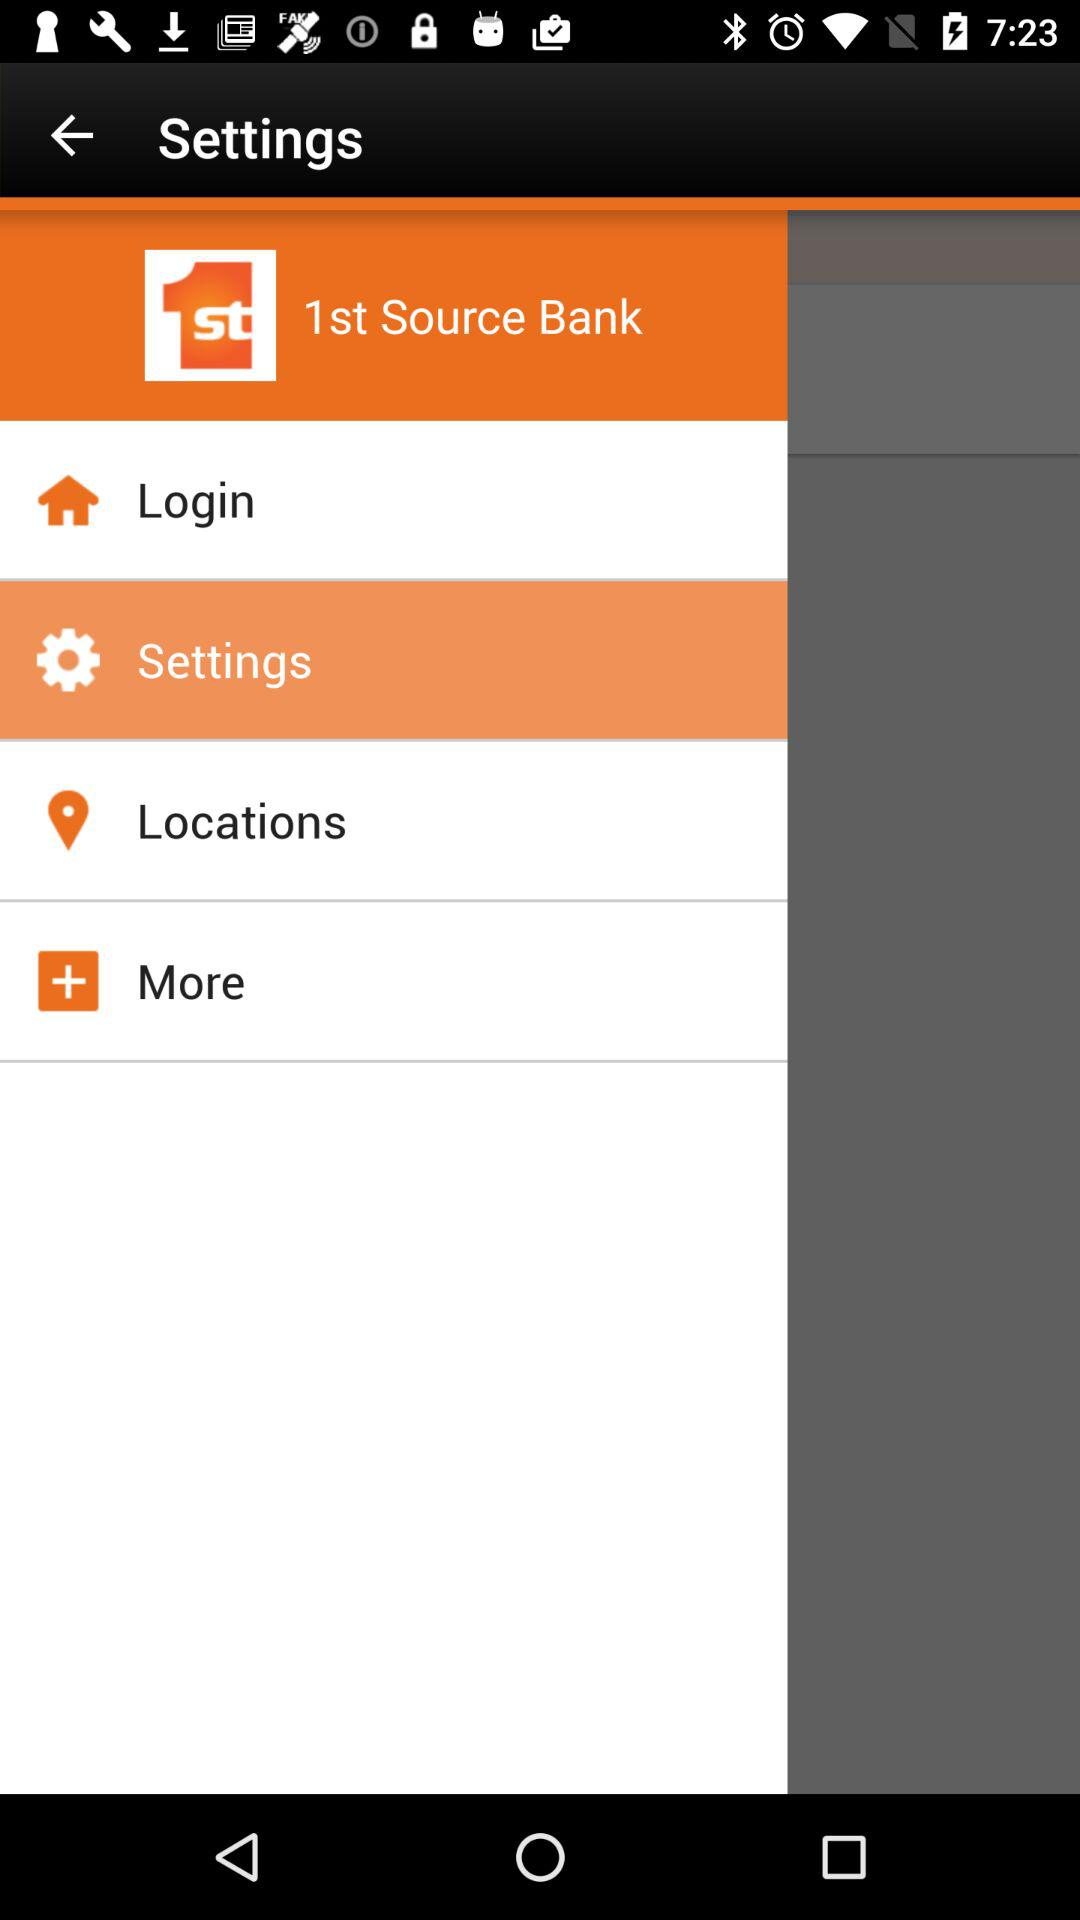Where is the nearest bank location?
When the provided information is insufficient, respond with <no answer>. <no answer> 